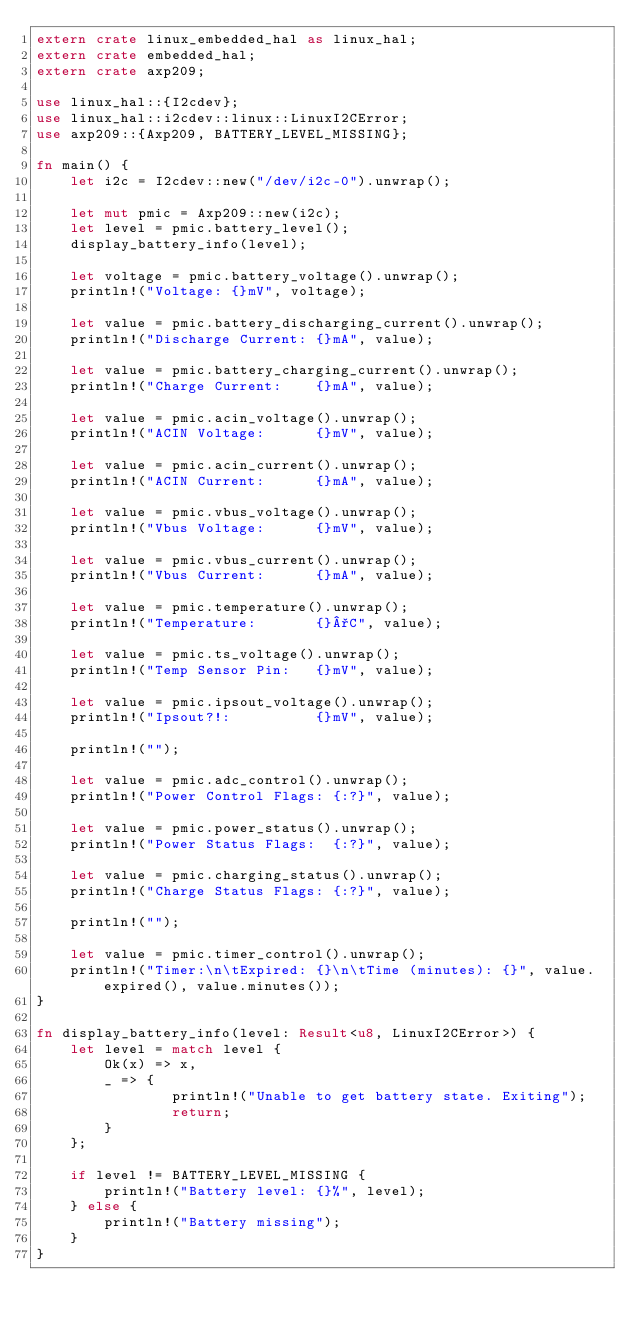<code> <loc_0><loc_0><loc_500><loc_500><_Rust_>extern crate linux_embedded_hal as linux_hal;
extern crate embedded_hal;
extern crate axp209;

use linux_hal::{I2cdev};
use linux_hal::i2cdev::linux::LinuxI2CError;
use axp209::{Axp209, BATTERY_LEVEL_MISSING};

fn main() {
    let i2c = I2cdev::new("/dev/i2c-0").unwrap();

    let mut pmic = Axp209::new(i2c);
    let level = pmic.battery_level();
    display_battery_info(level);

    let voltage = pmic.battery_voltage().unwrap();
    println!("Voltage: {}mV", voltage);

    let value = pmic.battery_discharging_current().unwrap();
    println!("Discharge Current: {}mA", value);

    let value = pmic.battery_charging_current().unwrap();
    println!("Charge Current:    {}mA", value);

    let value = pmic.acin_voltage().unwrap();
    println!("ACIN Voltage:      {}mV", value);

    let value = pmic.acin_current().unwrap();
    println!("ACIN Current:      {}mA", value);

    let value = pmic.vbus_voltage().unwrap();
    println!("Vbus Voltage:      {}mV", value);

    let value = pmic.vbus_current().unwrap();
    println!("Vbus Current:      {}mA", value);

    let value = pmic.temperature().unwrap();
    println!("Temperature:       {}°C", value);

    let value = pmic.ts_voltage().unwrap();
    println!("Temp Sensor Pin:   {}mV", value);

    let value = pmic.ipsout_voltage().unwrap();
    println!("Ipsout?!:          {}mV", value);

    println!("");

    let value = pmic.adc_control().unwrap();
    println!("Power Control Flags: {:?}", value);

    let value = pmic.power_status().unwrap();
    println!("Power Status Flags:  {:?}", value);

    let value = pmic.charging_status().unwrap();
    println!("Charge Status Flags: {:?}", value);

    println!("");

    let value = pmic.timer_control().unwrap();
    println!("Timer:\n\tExpired: {}\n\tTime (minutes): {}", value.expired(), value.minutes());
}

fn display_battery_info(level: Result<u8, LinuxI2CError>) {
    let level = match level {
        Ok(x) => x,
        _ => { 
                println!("Unable to get battery state. Exiting");
                return;
        }
    };

    if level != BATTERY_LEVEL_MISSING {
        println!("Battery level: {}%", level);
    } else {
        println!("Battery missing");
    }
}
</code> 